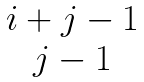<formula> <loc_0><loc_0><loc_500><loc_500>\begin{matrix} i + j - 1 \\ j - 1 \end{matrix}</formula> 